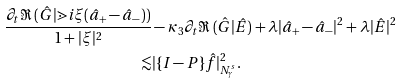<formula> <loc_0><loc_0><loc_500><loc_500>\frac { \partial _ { t } \Re \, ( \hat { G } | \mathbb { m } { i } \xi ( \hat { a } _ { + } - \hat { a } _ { - } ) ) } { 1 + | \xi | ^ { 2 } } & - \kappa _ { 3 } \partial _ { t } \Re \, ( \hat { G } | \hat { E } ) + \lambda | \hat { a } _ { + } - \hat { a } _ { - } | ^ { 2 } + \lambda | \hat { E } | ^ { 2 } \\ \lesssim & | \{ { I } - { P } \} \hat { f } | _ { N ^ { s } _ { \gamma } } ^ { 2 } .</formula> 